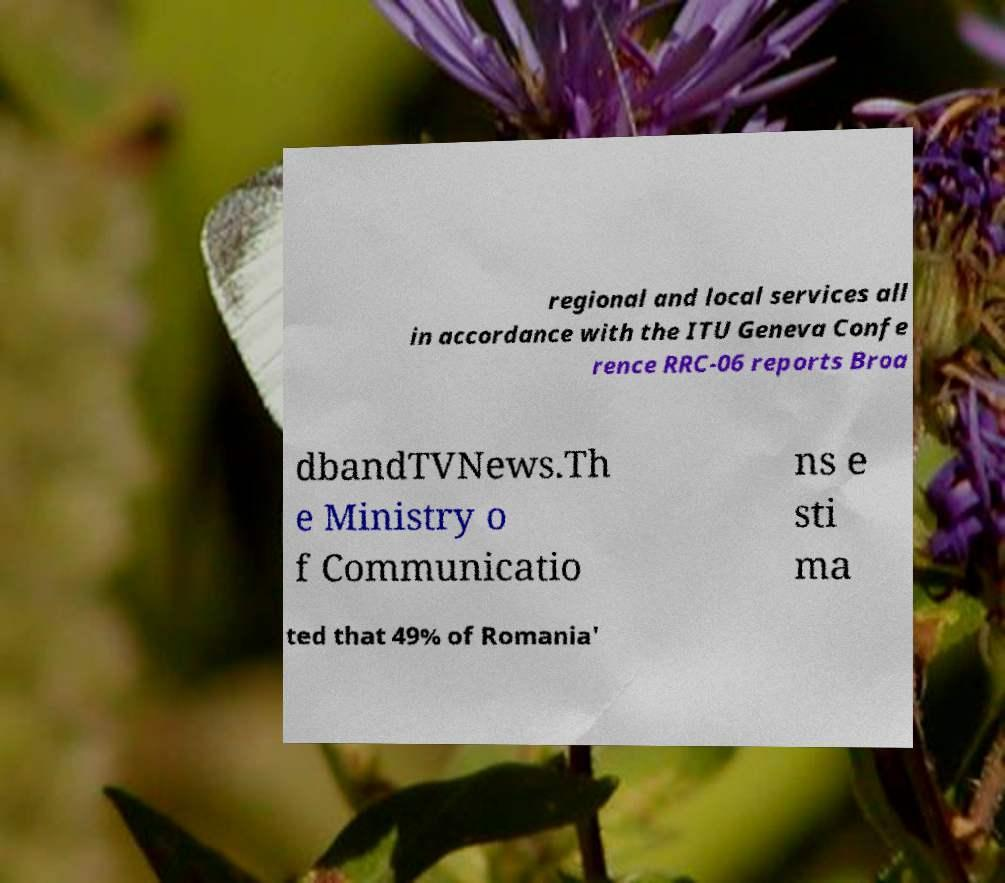Can you read and provide the text displayed in the image?This photo seems to have some interesting text. Can you extract and type it out for me? regional and local services all in accordance with the ITU Geneva Confe rence RRC-06 reports Broa dbandTVNews.Th e Ministry o f Communicatio ns e sti ma ted that 49% of Romania' 